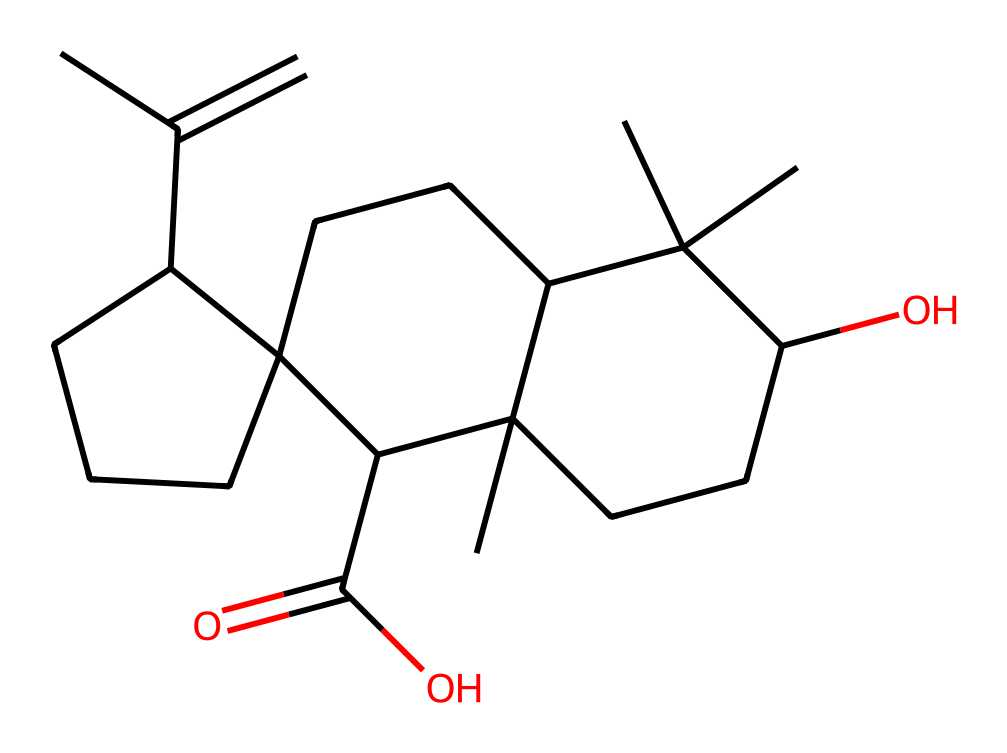What is the number of carbon atoms in this structure? Count the number of carbon atoms represented in the SMILES. Each "C" in the structure denotes a carbon atom. By counting them, we find there are 27 carbon atoms present.
Answer: 27 What type of functional group is present in this chemical? Analyze the structure for any specific features or groups. The presence of –O (hydroxyl) and –C(=O)O (carboxylic acid) indicates functional groups. Thus, the compound contains a carboxylic acid group and an alcohol group.
Answer: carboxylic acid and alcohol How many rings are present in this hydrocarbon structure? Examine the connections between carbon atoms and identify any closed loops. The SMILES notation indicates there are multiple ring structures formed, specifically three rings.
Answer: 3 Does this compound have any double bonds? Look for occurrences of double bonds in the carbon atoms in the structure. The notation "C=C" within the structure shows that there are double bonds present, specifically C=C in the cyclic portions.
Answer: Yes What is the molecular formula of this hydrocarbon? To find the molecular formula, tally up the number of each type of atom from the SMILES. There are 27 carbon atoms, 46 hydrogen atoms, and 4 oxygen atoms, leading to the formula C27H46O4.
Answer: C27H46O4 